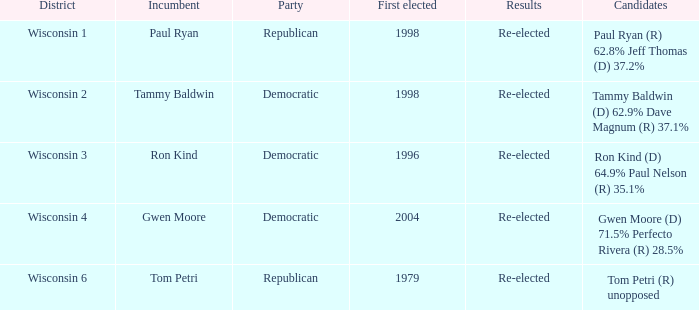What district first elected a Democratic incumbent in 1998? Wisconsin 2. 